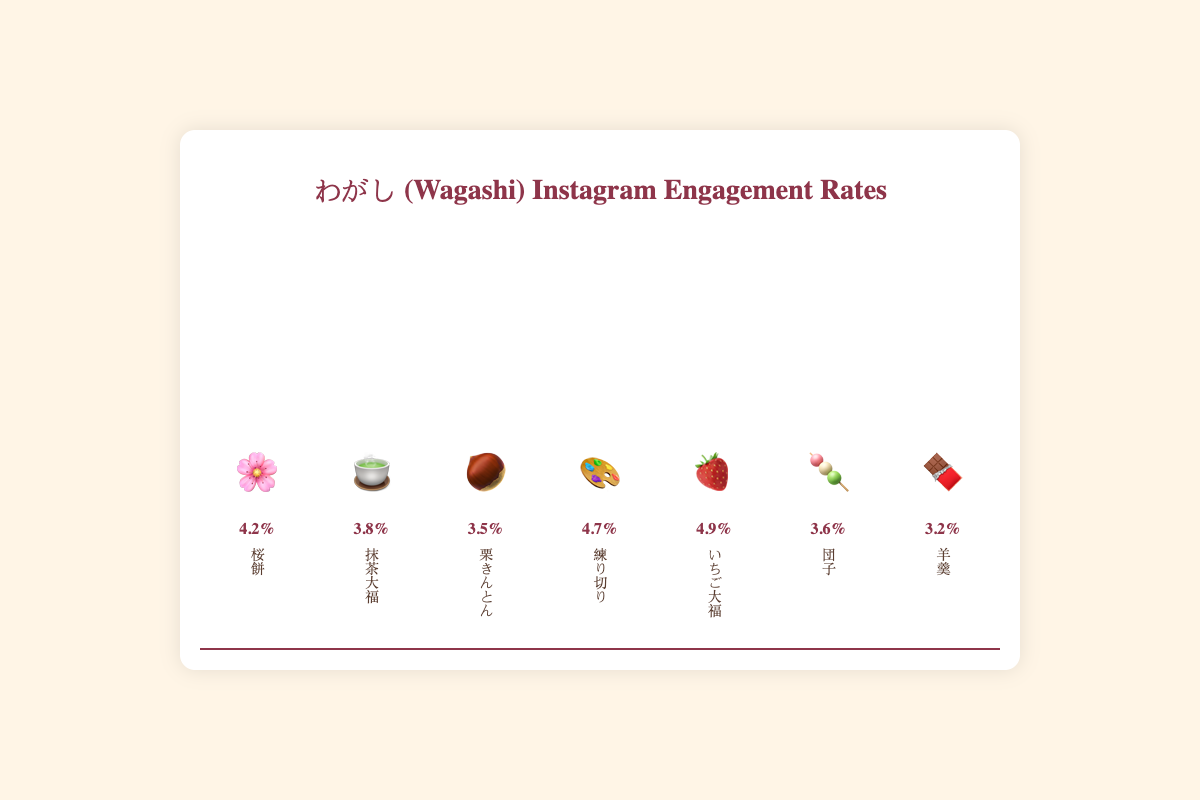Which wagashi design has the highest Instagram engagement rate? Observe the heights of the bars in the chart and find the tallest one. The tallest bar is associated with "Ichigo Daifuku" 🍓.
Answer: Ichigo Daifuku 🍓 Which wagashi design has the lowest Instagram engagement rate? Look for the shortest bar. The shortest bar corresponds to "Yokan" 🍫.
Answer: Yokan 🍫 What is the difference in engagement rate between Sakura Mochi 🌸 and Ichigo Daifuku 🍓? Sakura Mochi has an engagement rate of 4.2% and Ichigo Daifuku has an engagement rate of 4.9%. Subtract the smaller rate from the larger rate: 4.9 - 4.2 = 0.7.
Answer: 0.7% What is the average engagement rate of all wagashi designs? Sum the engagement rates of all designs and divide by the number of designs: (4.2 + 3.8 + 3.5 + 4.7 + 4.9 + 3.6 + 3.2) / 7.
Answer: 3.985% Which wagashi design has an engagement rate closest to the median engagement rate? First, list the engagement rates in ascending order: 3.2, 3.5, 3.6, 3.8, 4.2, 4.7, 4.9. The median value is the middle one: 3.8, corresponding to "Matcha Daifuku" 🍵.
Answer: Matcha Daifuku 🍵 How many wagashi designs have an engagement rate above 4.0%? Identify and count the bars with engagement rates above 4.0%. They are: Sakura Mochi 🌸, Nerikiri 🎨, Ichigo Daifuku 🍓.
Answer: 3 Compare the engagement rates of Kuri Kinton 🌰 and Dango 🍡. Which one is higher? Kuri Kinton (3.5%) and Dango (3.6%), so Dango's rate is higher.
Answer: Dango 🍡 Which wagashi designs have engagement rates within 0.1% of 3.5%? Check the engagement rates close to 3.5% (±0.1%). Only Kuri Kinton 🌰 meets this criterion with 3.5%.
Answer: Kuri Kinton 🌰 